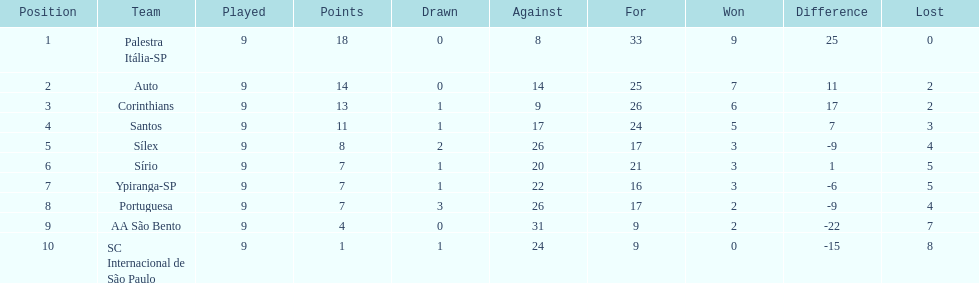In 1926 brazilian football,what was the total number of points scored? 90. 